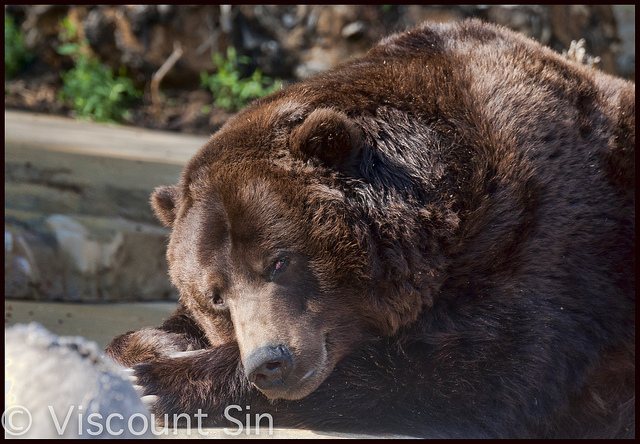Identify the text contained in this image. Viscount Sin 